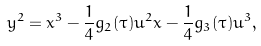<formula> <loc_0><loc_0><loc_500><loc_500>y ^ { 2 } = x ^ { 3 } - \frac { 1 } { 4 } g _ { 2 } ( \tau ) u ^ { 2 } x - \frac { 1 } { 4 } g _ { 3 } ( \tau ) u ^ { 3 } ,</formula> 